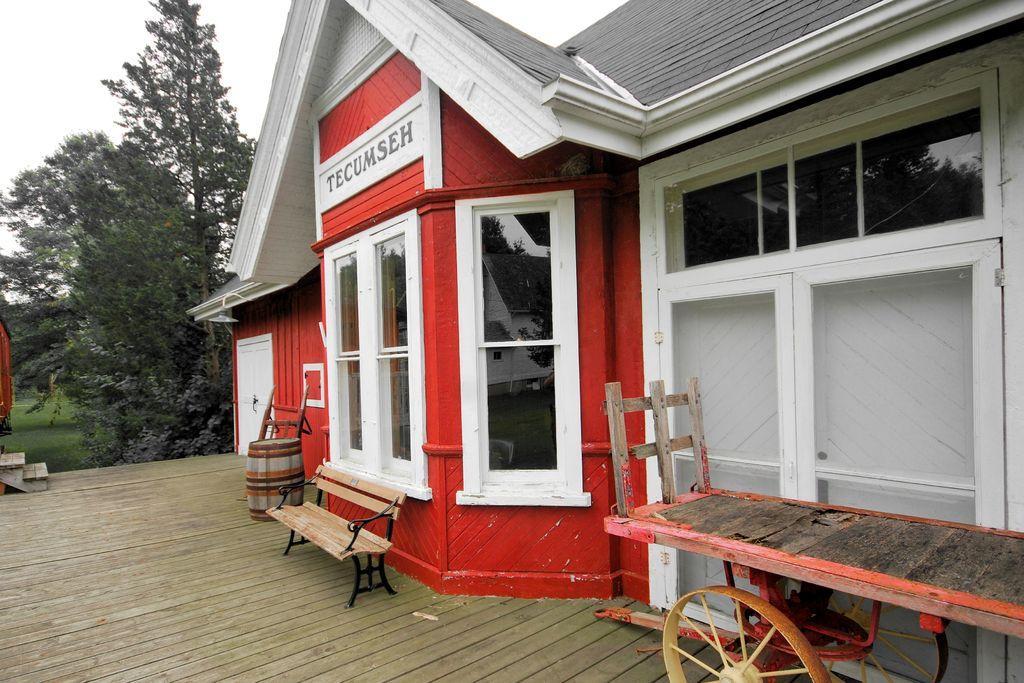In one or two sentences, can you explain what this image depicts? We can see house. On the background we can see trees and sky. This is floor. We can see bench,We can see cart. 